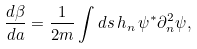<formula> <loc_0><loc_0><loc_500><loc_500>\frac { d \beta } { d a } = \frac { 1 } { 2 m } \int d s \, h _ { n } \, \psi ^ { * } \partial ^ { 2 } _ { n } \psi ,</formula> 